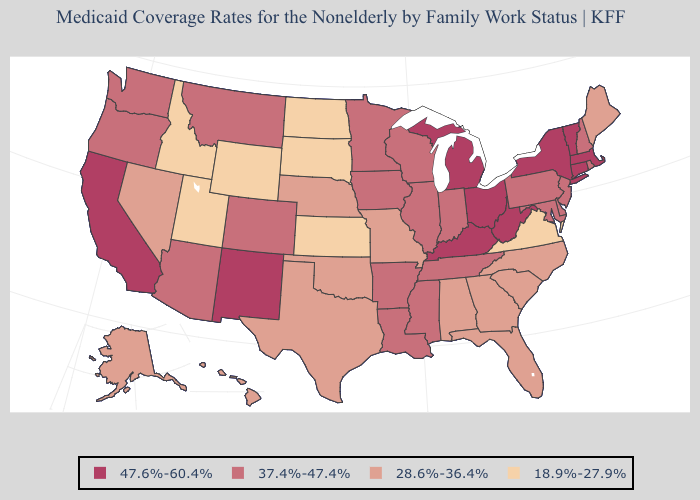Does the map have missing data?
Short answer required. No. Among the states that border Tennessee , which have the highest value?
Concise answer only. Kentucky. Does Idaho have the lowest value in the USA?
Write a very short answer. Yes. Does North Dakota have a lower value than South Dakota?
Answer briefly. No. Does Louisiana have a higher value than Alabama?
Keep it brief. Yes. How many symbols are there in the legend?
Give a very brief answer. 4. What is the lowest value in the USA?
Write a very short answer. 18.9%-27.9%. How many symbols are there in the legend?
Be succinct. 4. Does the first symbol in the legend represent the smallest category?
Be succinct. No. Which states have the lowest value in the USA?
Short answer required. Idaho, Kansas, North Dakota, South Dakota, Utah, Virginia, Wyoming. Does Oregon have the same value as Arkansas?
Be succinct. Yes. What is the value of Washington?
Quick response, please. 37.4%-47.4%. What is the value of Idaho?
Write a very short answer. 18.9%-27.9%. Does South Dakota have the lowest value in the MidWest?
Answer briefly. Yes. Name the states that have a value in the range 28.6%-36.4%?
Give a very brief answer. Alabama, Alaska, Florida, Georgia, Hawaii, Maine, Missouri, Nebraska, Nevada, North Carolina, Oklahoma, South Carolina, Texas. 